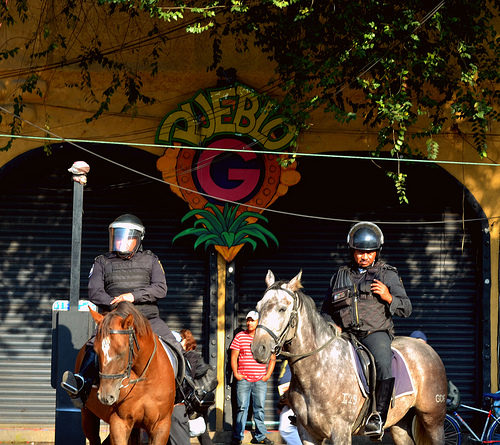Are there any other people in the image besides the police officers? Yes, there are at least three individuals visible behind the mounted police officers. They appear to be standing near the closed storefront, in the background of the image.  What is the demeanor of the officers and the horses? The officers appear vigilant and focused, possibly on crowd control or surveillance duties. The horses stand calm and composed, well-trained for their roles. 